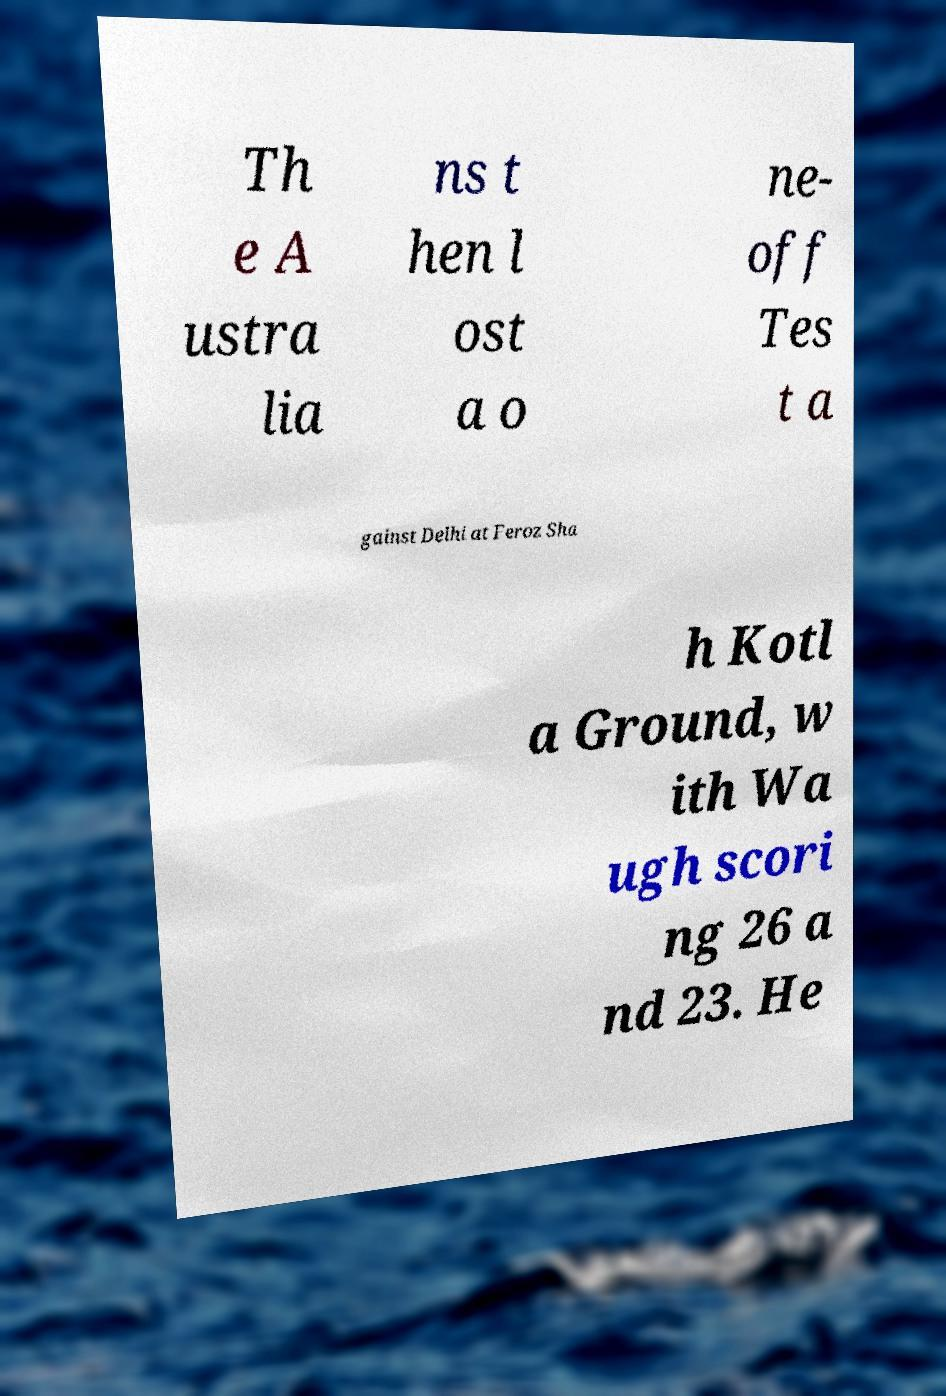Please identify and transcribe the text found in this image. Th e A ustra lia ns t hen l ost a o ne- off Tes t a gainst Delhi at Feroz Sha h Kotl a Ground, w ith Wa ugh scori ng 26 a nd 23. He 